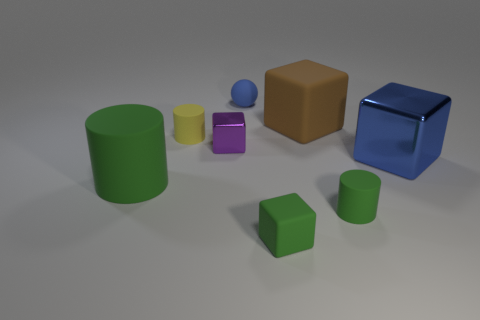There is a rubber thing that is both to the left of the tiny metal cube and in front of the big blue thing; what is its size?
Provide a succinct answer. Large. How many other things are there of the same material as the brown object?
Keep it short and to the point. 5. There is a matte block that is behind the big green matte object; how big is it?
Your answer should be compact. Large. Is the large cylinder the same color as the tiny sphere?
Keep it short and to the point. No. What number of big things are purple shiny objects or purple matte balls?
Provide a succinct answer. 0. Is there any other thing that is the same color as the small ball?
Provide a succinct answer. Yes. Are there any tiny green rubber blocks on the left side of the big green matte cylinder?
Ensure brevity in your answer.  No. What is the size of the rubber cylinder in front of the green cylinder that is on the left side of the tiny yellow matte cylinder?
Ensure brevity in your answer.  Small. Is the number of tiny green matte blocks that are to the right of the yellow matte cylinder the same as the number of cylinders behind the tiny blue sphere?
Your answer should be compact. No. Are there any large objects that are left of the big rubber cylinder behind the tiny green matte cylinder?
Keep it short and to the point. No. 